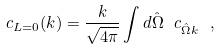<formula> <loc_0><loc_0><loc_500><loc_500>c _ { L = 0 } ( k ) = \frac { k } { \sqrt { 4 \pi } } \int d \hat { \Omega } \ c _ { \hat { \Omega } k } \ ,</formula> 